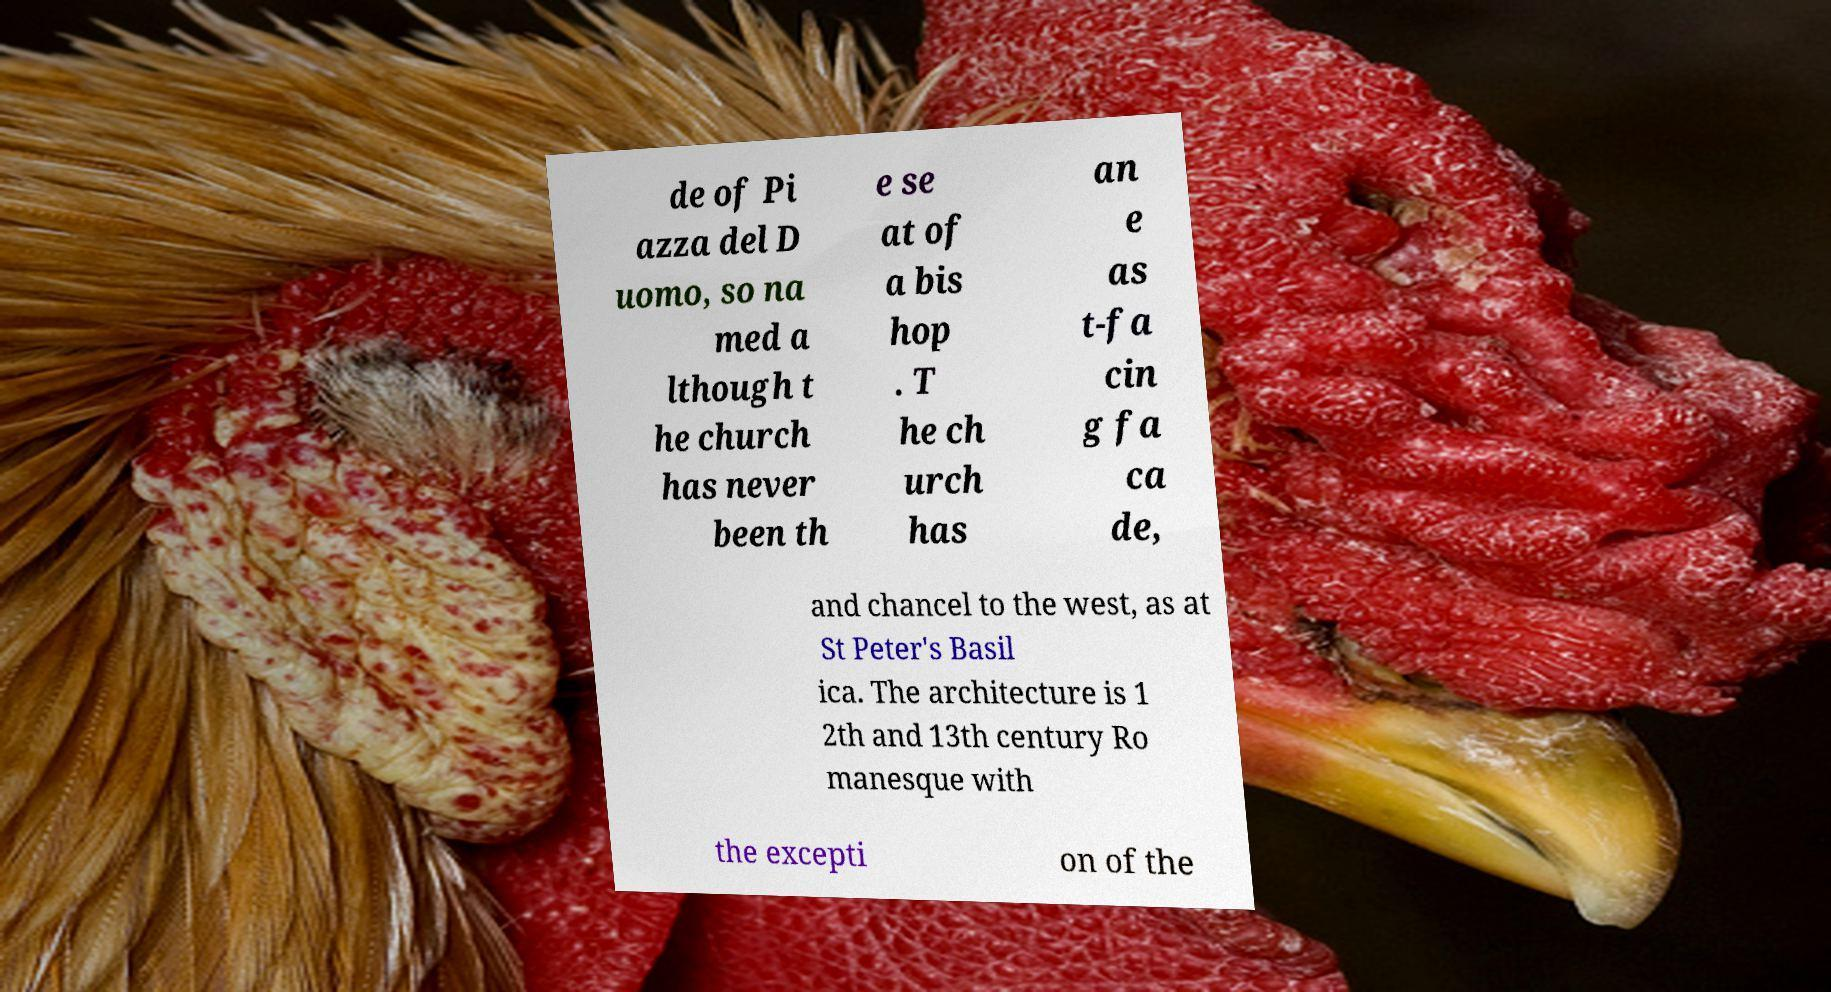Please identify and transcribe the text found in this image. de of Pi azza del D uomo, so na med a lthough t he church has never been th e se at of a bis hop . T he ch urch has an e as t-fa cin g fa ca de, and chancel to the west, as at St Peter's Basil ica. The architecture is 1 2th and 13th century Ro manesque with the excepti on of the 